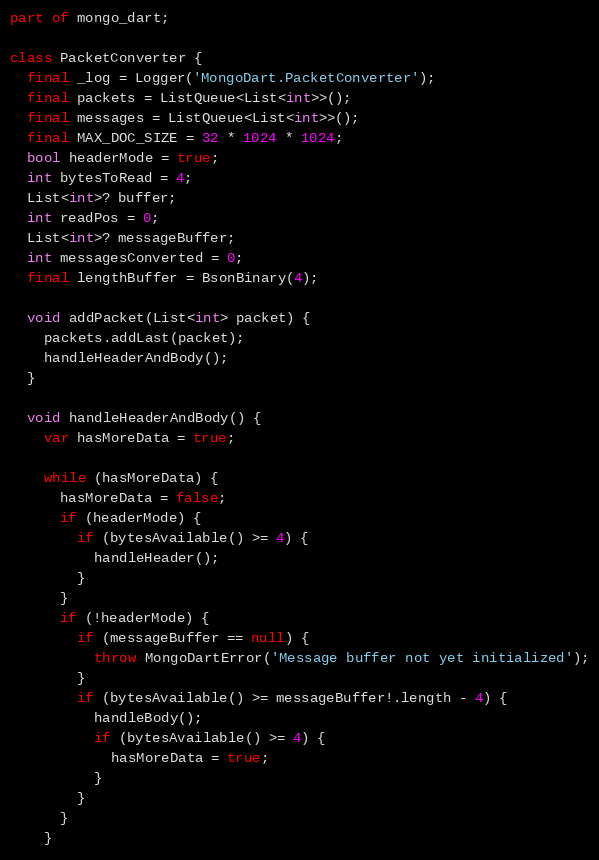<code> <loc_0><loc_0><loc_500><loc_500><_Dart_>part of mongo_dart;

class PacketConverter {
  final _log = Logger('MongoDart.PacketConverter');
  final packets = ListQueue<List<int>>();
  final messages = ListQueue<List<int>>();
  final MAX_DOC_SIZE = 32 * 1024 * 1024;
  bool headerMode = true;
  int bytesToRead = 4;
  List<int>? buffer;
  int readPos = 0;
  List<int>? messageBuffer;
  int messagesConverted = 0;
  final lengthBuffer = BsonBinary(4);

  void addPacket(List<int> packet) {
    packets.addLast(packet);
    handleHeaderAndBody();
  }

  void handleHeaderAndBody() {
    var hasMoreData = true;

    while (hasMoreData) {
      hasMoreData = false;
      if (headerMode) {
        if (bytesAvailable() >= 4) {
          handleHeader();
        }
      }
      if (!headerMode) {
        if (messageBuffer == null) {
          throw MongoDartError('Message buffer not yet initialized');
        }
        if (bytesAvailable() >= messageBuffer!.length - 4) {
          handleBody();
          if (bytesAvailable() >= 4) {
            hasMoreData = true;
          }
        }
      }
    }</code> 